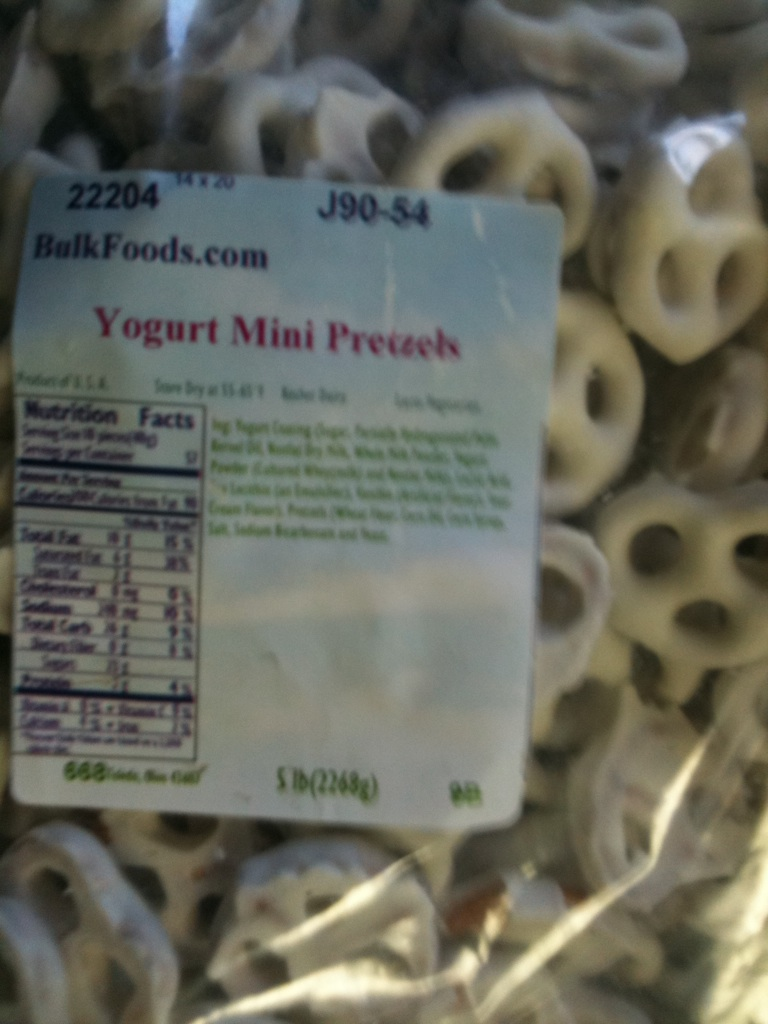What flavors can you taste in this snack? In Yogurt Mini Pretzels, you can experience a delightful combination of contrasting flavors. The crunchy, salty taste of the pretzel pairs wonderfully with the sweet and tangy yogurt coating, creating a balanced snack that is both satisfying and delicious. 